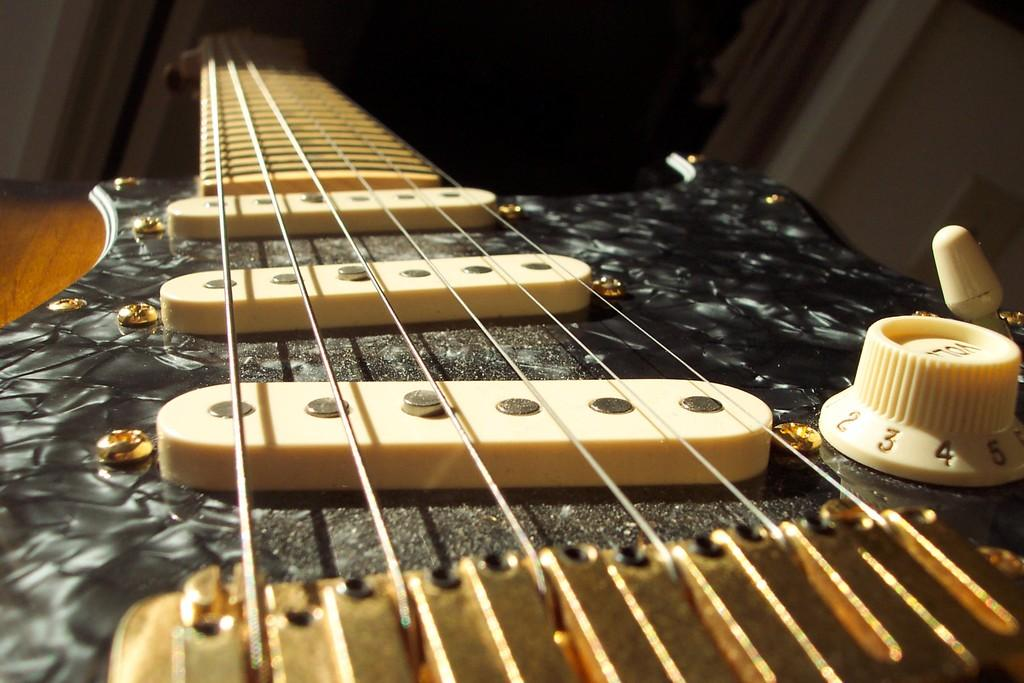What musical instrument is present in the image? There is a guitar in the image. Where is the guitar placed? The guitar is placed on a wooden surface. What can be observed about the lighting in the image? The background of the image is dark. What type of dinner is being served in the image? There is no dinner present in the image; it only features a guitar placed on a wooden surface with a dark background. 